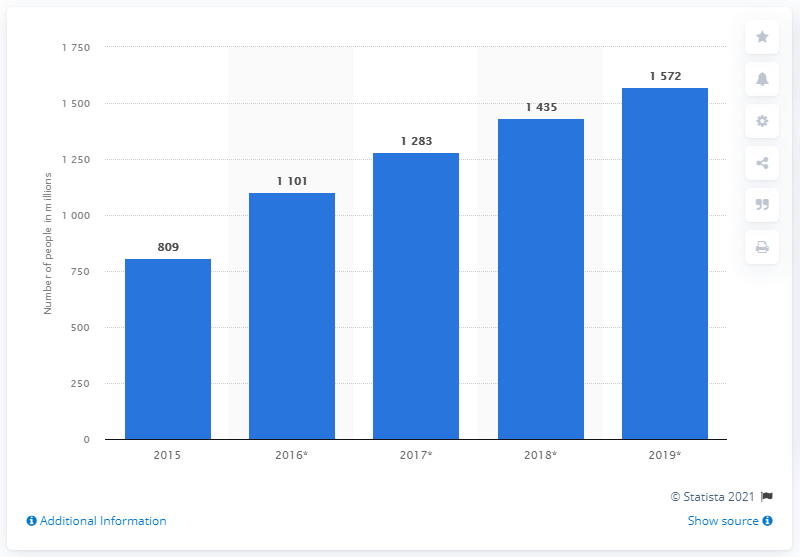Identify some key points in this picture. In 2015, it is estimated that approximately 809 million people worldwide were aware of eSports. In 2015, 809 million people were aware of eSports. In 2019, it is projected that a large number of people, approximately 1572, will be aware of eSports. 